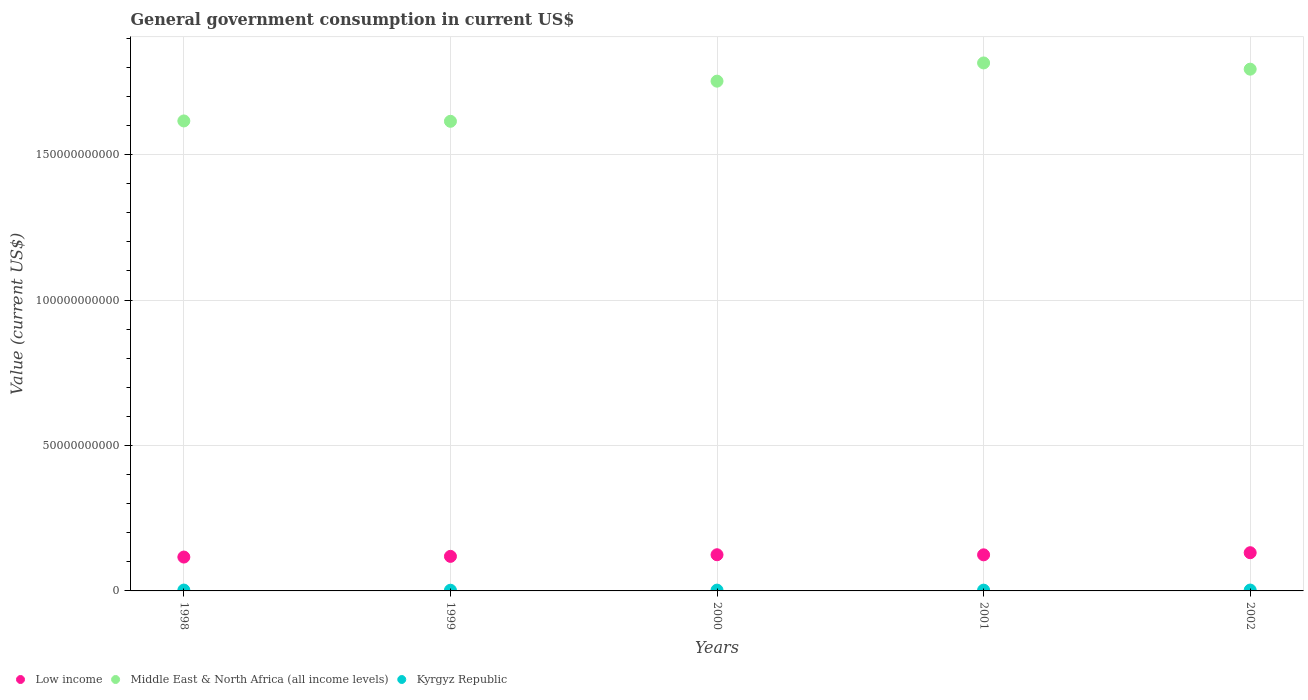How many different coloured dotlines are there?
Provide a succinct answer. 3. What is the government conusmption in Low income in 2001?
Give a very brief answer. 1.24e+1. Across all years, what is the maximum government conusmption in Low income?
Provide a succinct answer. 1.31e+1. Across all years, what is the minimum government conusmption in Middle East & North Africa (all income levels)?
Offer a terse response. 1.61e+11. What is the total government conusmption in Middle East & North Africa (all income levels) in the graph?
Keep it short and to the point. 8.59e+11. What is the difference between the government conusmption in Low income in 1998 and that in 2002?
Give a very brief answer. -1.50e+09. What is the difference between the government conusmption in Low income in 1998 and the government conusmption in Kyrgyz Republic in 2002?
Ensure brevity in your answer.  1.13e+1. What is the average government conusmption in Low income per year?
Your response must be concise. 1.23e+1. In the year 1999, what is the difference between the government conusmption in Low income and government conusmption in Middle East & North Africa (all income levels)?
Ensure brevity in your answer.  -1.50e+11. In how many years, is the government conusmption in Middle East & North Africa (all income levels) greater than 130000000000 US$?
Offer a terse response. 5. What is the ratio of the government conusmption in Kyrgyz Republic in 1998 to that in 2001?
Your answer should be compact. 1.1. Is the government conusmption in Kyrgyz Republic in 1998 less than that in 1999?
Offer a terse response. No. Is the difference between the government conusmption in Low income in 1998 and 1999 greater than the difference between the government conusmption in Middle East & North Africa (all income levels) in 1998 and 1999?
Keep it short and to the point. No. What is the difference between the highest and the second highest government conusmption in Low income?
Provide a short and direct response. 7.01e+08. What is the difference between the highest and the lowest government conusmption in Middle East & North Africa (all income levels)?
Offer a very short reply. 2.01e+1. In how many years, is the government conusmption in Low income greater than the average government conusmption in Low income taken over all years?
Your answer should be very brief. 3. Is the sum of the government conusmption in Low income in 2000 and 2001 greater than the maximum government conusmption in Middle East & North Africa (all income levels) across all years?
Give a very brief answer. No. Is it the case that in every year, the sum of the government conusmption in Kyrgyz Republic and government conusmption in Low income  is greater than the government conusmption in Middle East & North Africa (all income levels)?
Keep it short and to the point. No. Does the government conusmption in Kyrgyz Republic monotonically increase over the years?
Ensure brevity in your answer.  No. Is the government conusmption in Kyrgyz Republic strictly less than the government conusmption in Middle East & North Africa (all income levels) over the years?
Keep it short and to the point. Yes. How many years are there in the graph?
Your answer should be compact. 5. Are the values on the major ticks of Y-axis written in scientific E-notation?
Your answer should be compact. No. Does the graph contain grids?
Keep it short and to the point. Yes. How are the legend labels stacked?
Give a very brief answer. Horizontal. What is the title of the graph?
Ensure brevity in your answer.  General government consumption in current US$. Does "Turkey" appear as one of the legend labels in the graph?
Make the answer very short. No. What is the label or title of the X-axis?
Your response must be concise. Years. What is the label or title of the Y-axis?
Your answer should be very brief. Value (current US$). What is the Value (current US$) in Low income in 1998?
Your answer should be compact. 1.16e+1. What is the Value (current US$) of Middle East & North Africa (all income levels) in 1998?
Offer a very short reply. 1.62e+11. What is the Value (current US$) of Kyrgyz Republic in 1998?
Make the answer very short. 2.94e+08. What is the Value (current US$) in Low income in 1999?
Your answer should be very brief. 1.19e+1. What is the Value (current US$) of Middle East & North Africa (all income levels) in 1999?
Your response must be concise. 1.61e+11. What is the Value (current US$) of Kyrgyz Republic in 1999?
Your answer should be compact. 2.39e+08. What is the Value (current US$) of Low income in 2000?
Ensure brevity in your answer.  1.24e+1. What is the Value (current US$) of Middle East & North Africa (all income levels) in 2000?
Keep it short and to the point. 1.75e+11. What is the Value (current US$) of Kyrgyz Republic in 2000?
Provide a succinct answer. 2.75e+08. What is the Value (current US$) in Low income in 2001?
Your answer should be very brief. 1.24e+1. What is the Value (current US$) of Middle East & North Africa (all income levels) in 2001?
Your response must be concise. 1.81e+11. What is the Value (current US$) in Kyrgyz Republic in 2001?
Make the answer very short. 2.67e+08. What is the Value (current US$) in Low income in 2002?
Provide a succinct answer. 1.31e+1. What is the Value (current US$) of Middle East & North Africa (all income levels) in 2002?
Ensure brevity in your answer.  1.79e+11. What is the Value (current US$) of Kyrgyz Republic in 2002?
Your answer should be compact. 2.99e+08. Across all years, what is the maximum Value (current US$) of Low income?
Your answer should be compact. 1.31e+1. Across all years, what is the maximum Value (current US$) in Middle East & North Africa (all income levels)?
Make the answer very short. 1.81e+11. Across all years, what is the maximum Value (current US$) of Kyrgyz Republic?
Keep it short and to the point. 2.99e+08. Across all years, what is the minimum Value (current US$) of Low income?
Offer a terse response. 1.16e+1. Across all years, what is the minimum Value (current US$) in Middle East & North Africa (all income levels)?
Offer a very short reply. 1.61e+11. Across all years, what is the minimum Value (current US$) of Kyrgyz Republic?
Make the answer very short. 2.39e+08. What is the total Value (current US$) in Low income in the graph?
Keep it short and to the point. 6.15e+1. What is the total Value (current US$) of Middle East & North Africa (all income levels) in the graph?
Keep it short and to the point. 8.59e+11. What is the total Value (current US$) of Kyrgyz Republic in the graph?
Offer a very short reply. 1.37e+09. What is the difference between the Value (current US$) in Low income in 1998 and that in 1999?
Offer a very short reply. -2.37e+08. What is the difference between the Value (current US$) of Middle East & North Africa (all income levels) in 1998 and that in 1999?
Provide a succinct answer. 1.24e+08. What is the difference between the Value (current US$) in Kyrgyz Republic in 1998 and that in 1999?
Your response must be concise. 5.51e+07. What is the difference between the Value (current US$) in Low income in 1998 and that in 2000?
Ensure brevity in your answer.  -7.95e+08. What is the difference between the Value (current US$) of Middle East & North Africa (all income levels) in 1998 and that in 2000?
Keep it short and to the point. -1.37e+1. What is the difference between the Value (current US$) of Kyrgyz Republic in 1998 and that in 2000?
Keep it short and to the point. 1.94e+07. What is the difference between the Value (current US$) of Low income in 1998 and that in 2001?
Your response must be concise. -7.64e+08. What is the difference between the Value (current US$) in Middle East & North Africa (all income levels) in 1998 and that in 2001?
Ensure brevity in your answer.  -1.99e+1. What is the difference between the Value (current US$) of Kyrgyz Republic in 1998 and that in 2001?
Offer a terse response. 2.74e+07. What is the difference between the Value (current US$) in Low income in 1998 and that in 2002?
Your answer should be very brief. -1.50e+09. What is the difference between the Value (current US$) in Middle East & North Africa (all income levels) in 1998 and that in 2002?
Give a very brief answer. -1.78e+1. What is the difference between the Value (current US$) in Kyrgyz Republic in 1998 and that in 2002?
Make the answer very short. -5.08e+06. What is the difference between the Value (current US$) in Low income in 1999 and that in 2000?
Offer a terse response. -5.58e+08. What is the difference between the Value (current US$) of Middle East & North Africa (all income levels) in 1999 and that in 2000?
Keep it short and to the point. -1.38e+1. What is the difference between the Value (current US$) in Kyrgyz Republic in 1999 and that in 2000?
Your answer should be very brief. -3.57e+07. What is the difference between the Value (current US$) in Low income in 1999 and that in 2001?
Your response must be concise. -5.27e+08. What is the difference between the Value (current US$) in Middle East & North Africa (all income levels) in 1999 and that in 2001?
Offer a terse response. -2.01e+1. What is the difference between the Value (current US$) of Kyrgyz Republic in 1999 and that in 2001?
Keep it short and to the point. -2.77e+07. What is the difference between the Value (current US$) in Low income in 1999 and that in 2002?
Provide a short and direct response. -1.26e+09. What is the difference between the Value (current US$) in Middle East & North Africa (all income levels) in 1999 and that in 2002?
Keep it short and to the point. -1.79e+1. What is the difference between the Value (current US$) in Kyrgyz Republic in 1999 and that in 2002?
Your answer should be very brief. -6.01e+07. What is the difference between the Value (current US$) in Low income in 2000 and that in 2001?
Offer a very short reply. 3.06e+07. What is the difference between the Value (current US$) in Middle East & North Africa (all income levels) in 2000 and that in 2001?
Your response must be concise. -6.26e+09. What is the difference between the Value (current US$) in Kyrgyz Republic in 2000 and that in 2001?
Your answer should be very brief. 7.98e+06. What is the difference between the Value (current US$) in Low income in 2000 and that in 2002?
Give a very brief answer. -7.01e+08. What is the difference between the Value (current US$) of Middle East & North Africa (all income levels) in 2000 and that in 2002?
Give a very brief answer. -4.12e+09. What is the difference between the Value (current US$) of Kyrgyz Republic in 2000 and that in 2002?
Your answer should be compact. -2.45e+07. What is the difference between the Value (current US$) of Low income in 2001 and that in 2002?
Your answer should be very brief. -7.31e+08. What is the difference between the Value (current US$) of Middle East & North Africa (all income levels) in 2001 and that in 2002?
Ensure brevity in your answer.  2.14e+09. What is the difference between the Value (current US$) of Kyrgyz Republic in 2001 and that in 2002?
Give a very brief answer. -3.24e+07. What is the difference between the Value (current US$) in Low income in 1998 and the Value (current US$) in Middle East & North Africa (all income levels) in 1999?
Your answer should be very brief. -1.50e+11. What is the difference between the Value (current US$) of Low income in 1998 and the Value (current US$) of Kyrgyz Republic in 1999?
Provide a succinct answer. 1.14e+1. What is the difference between the Value (current US$) of Middle East & North Africa (all income levels) in 1998 and the Value (current US$) of Kyrgyz Republic in 1999?
Offer a very short reply. 1.61e+11. What is the difference between the Value (current US$) of Low income in 1998 and the Value (current US$) of Middle East & North Africa (all income levels) in 2000?
Provide a succinct answer. -1.64e+11. What is the difference between the Value (current US$) in Low income in 1998 and the Value (current US$) in Kyrgyz Republic in 2000?
Offer a very short reply. 1.14e+1. What is the difference between the Value (current US$) in Middle East & North Africa (all income levels) in 1998 and the Value (current US$) in Kyrgyz Republic in 2000?
Your response must be concise. 1.61e+11. What is the difference between the Value (current US$) of Low income in 1998 and the Value (current US$) of Middle East & North Africa (all income levels) in 2001?
Your response must be concise. -1.70e+11. What is the difference between the Value (current US$) in Low income in 1998 and the Value (current US$) in Kyrgyz Republic in 2001?
Your answer should be compact. 1.14e+1. What is the difference between the Value (current US$) in Middle East & North Africa (all income levels) in 1998 and the Value (current US$) in Kyrgyz Republic in 2001?
Your answer should be very brief. 1.61e+11. What is the difference between the Value (current US$) of Low income in 1998 and the Value (current US$) of Middle East & North Africa (all income levels) in 2002?
Provide a short and direct response. -1.68e+11. What is the difference between the Value (current US$) of Low income in 1998 and the Value (current US$) of Kyrgyz Republic in 2002?
Your response must be concise. 1.13e+1. What is the difference between the Value (current US$) of Middle East & North Africa (all income levels) in 1998 and the Value (current US$) of Kyrgyz Republic in 2002?
Your answer should be compact. 1.61e+11. What is the difference between the Value (current US$) of Low income in 1999 and the Value (current US$) of Middle East & North Africa (all income levels) in 2000?
Ensure brevity in your answer.  -1.63e+11. What is the difference between the Value (current US$) of Low income in 1999 and the Value (current US$) of Kyrgyz Republic in 2000?
Your answer should be compact. 1.16e+1. What is the difference between the Value (current US$) in Middle East & North Africa (all income levels) in 1999 and the Value (current US$) in Kyrgyz Republic in 2000?
Offer a very short reply. 1.61e+11. What is the difference between the Value (current US$) in Low income in 1999 and the Value (current US$) in Middle East & North Africa (all income levels) in 2001?
Offer a very short reply. -1.70e+11. What is the difference between the Value (current US$) of Low income in 1999 and the Value (current US$) of Kyrgyz Republic in 2001?
Your answer should be very brief. 1.16e+1. What is the difference between the Value (current US$) of Middle East & North Africa (all income levels) in 1999 and the Value (current US$) of Kyrgyz Republic in 2001?
Give a very brief answer. 1.61e+11. What is the difference between the Value (current US$) in Low income in 1999 and the Value (current US$) in Middle East & North Africa (all income levels) in 2002?
Provide a short and direct response. -1.67e+11. What is the difference between the Value (current US$) in Low income in 1999 and the Value (current US$) in Kyrgyz Republic in 2002?
Make the answer very short. 1.16e+1. What is the difference between the Value (current US$) in Middle East & North Africa (all income levels) in 1999 and the Value (current US$) in Kyrgyz Republic in 2002?
Make the answer very short. 1.61e+11. What is the difference between the Value (current US$) of Low income in 2000 and the Value (current US$) of Middle East & North Africa (all income levels) in 2001?
Ensure brevity in your answer.  -1.69e+11. What is the difference between the Value (current US$) in Low income in 2000 and the Value (current US$) in Kyrgyz Republic in 2001?
Provide a short and direct response. 1.22e+1. What is the difference between the Value (current US$) of Middle East & North Africa (all income levels) in 2000 and the Value (current US$) of Kyrgyz Republic in 2001?
Make the answer very short. 1.75e+11. What is the difference between the Value (current US$) of Low income in 2000 and the Value (current US$) of Middle East & North Africa (all income levels) in 2002?
Ensure brevity in your answer.  -1.67e+11. What is the difference between the Value (current US$) in Low income in 2000 and the Value (current US$) in Kyrgyz Republic in 2002?
Offer a very short reply. 1.21e+1. What is the difference between the Value (current US$) in Middle East & North Africa (all income levels) in 2000 and the Value (current US$) in Kyrgyz Republic in 2002?
Offer a terse response. 1.75e+11. What is the difference between the Value (current US$) of Low income in 2001 and the Value (current US$) of Middle East & North Africa (all income levels) in 2002?
Give a very brief answer. -1.67e+11. What is the difference between the Value (current US$) of Low income in 2001 and the Value (current US$) of Kyrgyz Republic in 2002?
Provide a short and direct response. 1.21e+1. What is the difference between the Value (current US$) of Middle East & North Africa (all income levels) in 2001 and the Value (current US$) of Kyrgyz Republic in 2002?
Provide a short and direct response. 1.81e+11. What is the average Value (current US$) of Low income per year?
Provide a short and direct response. 1.23e+1. What is the average Value (current US$) of Middle East & North Africa (all income levels) per year?
Give a very brief answer. 1.72e+11. What is the average Value (current US$) of Kyrgyz Republic per year?
Make the answer very short. 2.75e+08. In the year 1998, what is the difference between the Value (current US$) in Low income and Value (current US$) in Middle East & North Africa (all income levels)?
Make the answer very short. -1.50e+11. In the year 1998, what is the difference between the Value (current US$) in Low income and Value (current US$) in Kyrgyz Republic?
Your response must be concise. 1.13e+1. In the year 1998, what is the difference between the Value (current US$) of Middle East & North Africa (all income levels) and Value (current US$) of Kyrgyz Republic?
Your answer should be compact. 1.61e+11. In the year 1999, what is the difference between the Value (current US$) in Low income and Value (current US$) in Middle East & North Africa (all income levels)?
Keep it short and to the point. -1.50e+11. In the year 1999, what is the difference between the Value (current US$) in Low income and Value (current US$) in Kyrgyz Republic?
Provide a succinct answer. 1.16e+1. In the year 1999, what is the difference between the Value (current US$) in Middle East & North Africa (all income levels) and Value (current US$) in Kyrgyz Republic?
Give a very brief answer. 1.61e+11. In the year 2000, what is the difference between the Value (current US$) of Low income and Value (current US$) of Middle East & North Africa (all income levels)?
Your response must be concise. -1.63e+11. In the year 2000, what is the difference between the Value (current US$) of Low income and Value (current US$) of Kyrgyz Republic?
Provide a succinct answer. 1.22e+1. In the year 2000, what is the difference between the Value (current US$) in Middle East & North Africa (all income levels) and Value (current US$) in Kyrgyz Republic?
Offer a terse response. 1.75e+11. In the year 2001, what is the difference between the Value (current US$) of Low income and Value (current US$) of Middle East & North Africa (all income levels)?
Your answer should be very brief. -1.69e+11. In the year 2001, what is the difference between the Value (current US$) in Low income and Value (current US$) in Kyrgyz Republic?
Offer a very short reply. 1.21e+1. In the year 2001, what is the difference between the Value (current US$) of Middle East & North Africa (all income levels) and Value (current US$) of Kyrgyz Republic?
Offer a very short reply. 1.81e+11. In the year 2002, what is the difference between the Value (current US$) of Low income and Value (current US$) of Middle East & North Africa (all income levels)?
Provide a short and direct response. -1.66e+11. In the year 2002, what is the difference between the Value (current US$) in Low income and Value (current US$) in Kyrgyz Republic?
Your answer should be very brief. 1.28e+1. In the year 2002, what is the difference between the Value (current US$) in Middle East & North Africa (all income levels) and Value (current US$) in Kyrgyz Republic?
Provide a short and direct response. 1.79e+11. What is the ratio of the Value (current US$) in Low income in 1998 to that in 1999?
Offer a terse response. 0.98. What is the ratio of the Value (current US$) in Middle East & North Africa (all income levels) in 1998 to that in 1999?
Keep it short and to the point. 1. What is the ratio of the Value (current US$) of Kyrgyz Republic in 1998 to that in 1999?
Make the answer very short. 1.23. What is the ratio of the Value (current US$) of Low income in 1998 to that in 2000?
Your answer should be compact. 0.94. What is the ratio of the Value (current US$) of Middle East & North Africa (all income levels) in 1998 to that in 2000?
Your answer should be very brief. 0.92. What is the ratio of the Value (current US$) of Kyrgyz Republic in 1998 to that in 2000?
Offer a terse response. 1.07. What is the ratio of the Value (current US$) in Low income in 1998 to that in 2001?
Offer a very short reply. 0.94. What is the ratio of the Value (current US$) in Middle East & North Africa (all income levels) in 1998 to that in 2001?
Offer a very short reply. 0.89. What is the ratio of the Value (current US$) of Kyrgyz Republic in 1998 to that in 2001?
Your answer should be compact. 1.1. What is the ratio of the Value (current US$) of Low income in 1998 to that in 2002?
Ensure brevity in your answer.  0.89. What is the ratio of the Value (current US$) of Middle East & North Africa (all income levels) in 1998 to that in 2002?
Your response must be concise. 0.9. What is the ratio of the Value (current US$) of Kyrgyz Republic in 1998 to that in 2002?
Give a very brief answer. 0.98. What is the ratio of the Value (current US$) of Low income in 1999 to that in 2000?
Your response must be concise. 0.96. What is the ratio of the Value (current US$) in Middle East & North Africa (all income levels) in 1999 to that in 2000?
Provide a succinct answer. 0.92. What is the ratio of the Value (current US$) of Kyrgyz Republic in 1999 to that in 2000?
Your answer should be compact. 0.87. What is the ratio of the Value (current US$) of Low income in 1999 to that in 2001?
Your answer should be very brief. 0.96. What is the ratio of the Value (current US$) of Middle East & North Africa (all income levels) in 1999 to that in 2001?
Your answer should be very brief. 0.89. What is the ratio of the Value (current US$) of Kyrgyz Republic in 1999 to that in 2001?
Make the answer very short. 0.9. What is the ratio of the Value (current US$) of Low income in 1999 to that in 2002?
Your answer should be very brief. 0.9. What is the ratio of the Value (current US$) of Middle East & North Africa (all income levels) in 1999 to that in 2002?
Offer a very short reply. 0.9. What is the ratio of the Value (current US$) in Kyrgyz Republic in 1999 to that in 2002?
Offer a terse response. 0.8. What is the ratio of the Value (current US$) in Low income in 2000 to that in 2001?
Ensure brevity in your answer.  1. What is the ratio of the Value (current US$) in Middle East & North Africa (all income levels) in 2000 to that in 2001?
Your answer should be compact. 0.97. What is the ratio of the Value (current US$) in Kyrgyz Republic in 2000 to that in 2001?
Offer a very short reply. 1.03. What is the ratio of the Value (current US$) of Low income in 2000 to that in 2002?
Keep it short and to the point. 0.95. What is the ratio of the Value (current US$) in Middle East & North Africa (all income levels) in 2000 to that in 2002?
Provide a succinct answer. 0.98. What is the ratio of the Value (current US$) in Kyrgyz Republic in 2000 to that in 2002?
Your response must be concise. 0.92. What is the ratio of the Value (current US$) of Low income in 2001 to that in 2002?
Give a very brief answer. 0.94. What is the ratio of the Value (current US$) in Middle East & North Africa (all income levels) in 2001 to that in 2002?
Make the answer very short. 1.01. What is the ratio of the Value (current US$) in Kyrgyz Republic in 2001 to that in 2002?
Make the answer very short. 0.89. What is the difference between the highest and the second highest Value (current US$) in Low income?
Keep it short and to the point. 7.01e+08. What is the difference between the highest and the second highest Value (current US$) of Middle East & North Africa (all income levels)?
Your response must be concise. 2.14e+09. What is the difference between the highest and the second highest Value (current US$) in Kyrgyz Republic?
Make the answer very short. 5.08e+06. What is the difference between the highest and the lowest Value (current US$) of Low income?
Your answer should be very brief. 1.50e+09. What is the difference between the highest and the lowest Value (current US$) of Middle East & North Africa (all income levels)?
Ensure brevity in your answer.  2.01e+1. What is the difference between the highest and the lowest Value (current US$) in Kyrgyz Republic?
Your answer should be compact. 6.01e+07. 